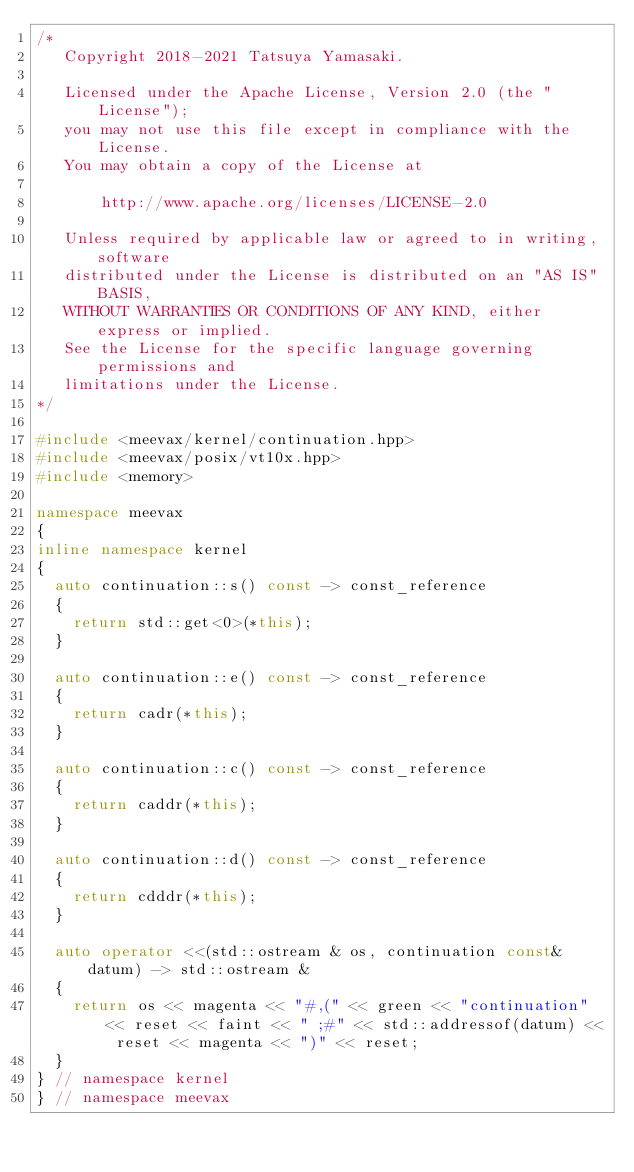<code> <loc_0><loc_0><loc_500><loc_500><_C++_>/*
   Copyright 2018-2021 Tatsuya Yamasaki.

   Licensed under the Apache License, Version 2.0 (the "License");
   you may not use this file except in compliance with the License.
   You may obtain a copy of the License at

       http://www.apache.org/licenses/LICENSE-2.0

   Unless required by applicable law or agreed to in writing, software
   distributed under the License is distributed on an "AS IS" BASIS,
   WITHOUT WARRANTIES OR CONDITIONS OF ANY KIND, either express or implied.
   See the License for the specific language governing permissions and
   limitations under the License.
*/

#include <meevax/kernel/continuation.hpp>
#include <meevax/posix/vt10x.hpp>
#include <memory>

namespace meevax
{
inline namespace kernel
{
  auto continuation::s() const -> const_reference
  {
    return std::get<0>(*this);
  }

  auto continuation::e() const -> const_reference
  {
    return cadr(*this);
  }

  auto continuation::c() const -> const_reference
  {
    return caddr(*this);
  }

  auto continuation::d() const -> const_reference
  {
    return cdddr(*this);
  }

  auto operator <<(std::ostream & os, continuation const& datum) -> std::ostream &
  {
    return os << magenta << "#,(" << green << "continuation" << reset << faint << " ;#" << std::addressof(datum) << reset << magenta << ")" << reset;
  }
} // namespace kernel
} // namespace meevax
</code> 